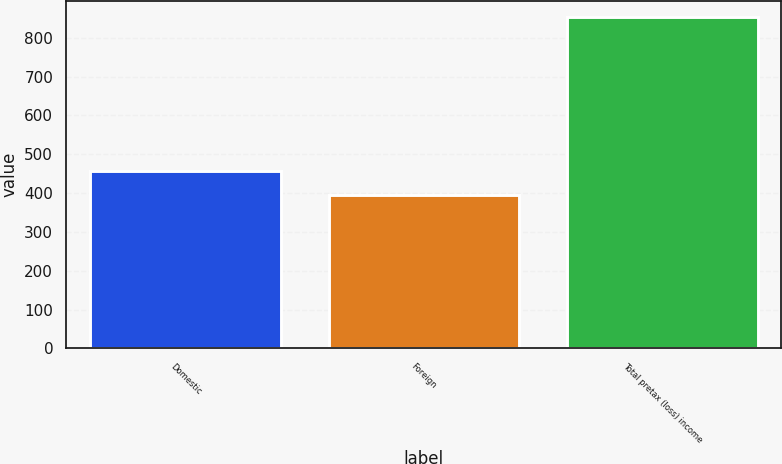Convert chart to OTSL. <chart><loc_0><loc_0><loc_500><loc_500><bar_chart><fcel>Domestic<fcel>Foreign<fcel>Total pretax (loss) income<nl><fcel>456.3<fcel>395.9<fcel>852.2<nl></chart> 